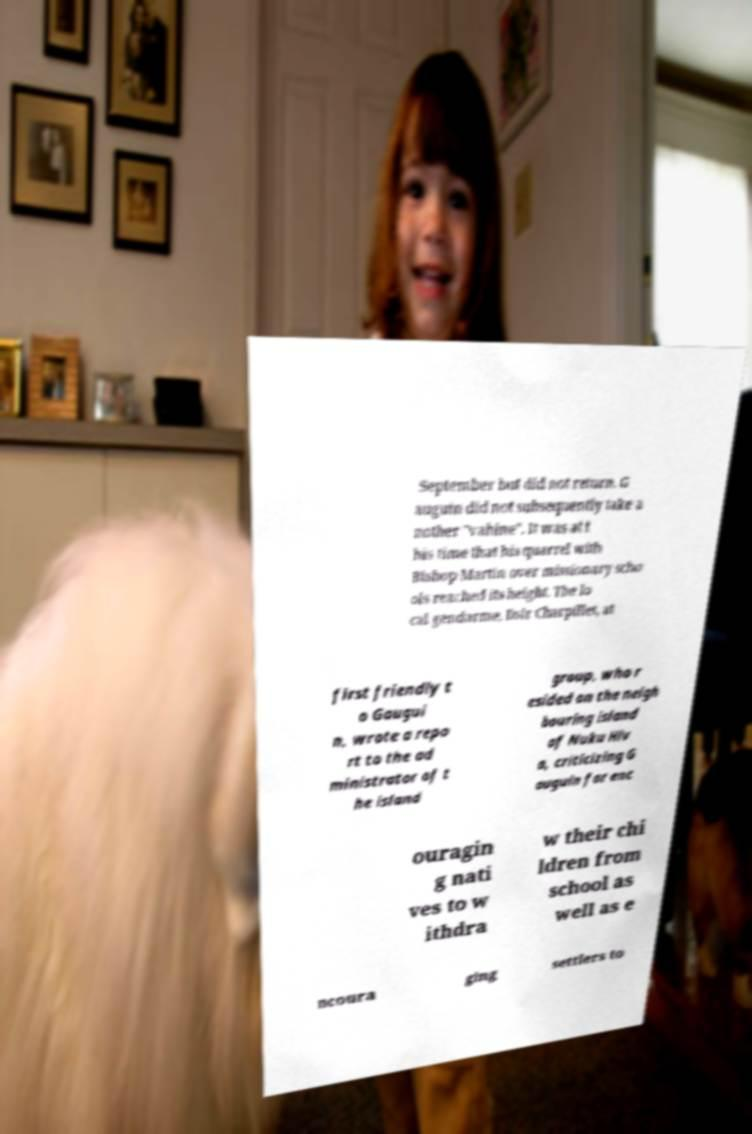There's text embedded in this image that I need extracted. Can you transcribe it verbatim? September but did not return. G auguin did not subsequently take a nother "vahine". It was at t his time that his quarrel with Bishop Martin over missionary scho ols reached its height. The lo cal gendarme, Dsir Charpillet, at first friendly t o Gaugui n, wrote a repo rt to the ad ministrator of t he island group, who r esided on the neigh bouring island of Nuku Hiv a, criticizing G auguin for enc ouragin g nati ves to w ithdra w their chi ldren from school as well as e ncoura ging settlers to 